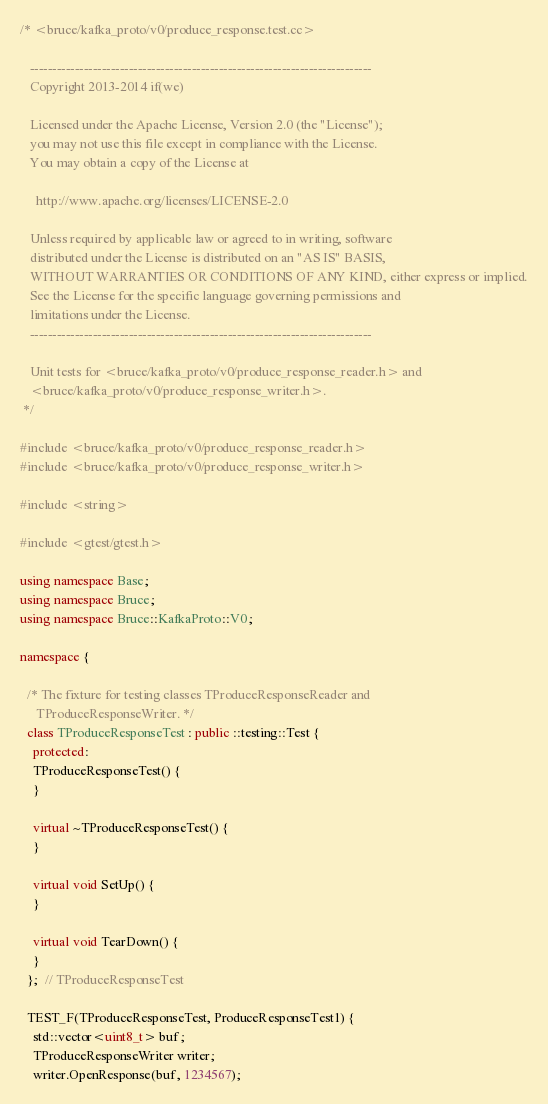Convert code to text. <code><loc_0><loc_0><loc_500><loc_500><_C++_>/* <bruce/kafka_proto/v0/produce_response.test.cc>

   ----------------------------------------------------------------------------
   Copyright 2013-2014 if(we)

   Licensed under the Apache License, Version 2.0 (the "License");
   you may not use this file except in compliance with the License.
   You may obtain a copy of the License at

     http://www.apache.org/licenses/LICENSE-2.0

   Unless required by applicable law or agreed to in writing, software
   distributed under the License is distributed on an "AS IS" BASIS,
   WITHOUT WARRANTIES OR CONDITIONS OF ANY KIND, either express or implied.
   See the License for the specific language governing permissions and
   limitations under the License.
   ----------------------------------------------------------------------------

   Unit tests for <bruce/kafka_proto/v0/produce_response_reader.h> and
   <bruce/kafka_proto/v0/produce_response_writer.h>.
 */

#include <bruce/kafka_proto/v0/produce_response_reader.h>
#include <bruce/kafka_proto/v0/produce_response_writer.h>

#include <string>

#include <gtest/gtest.h>

using namespace Base;
using namespace Bruce;
using namespace Bruce::KafkaProto::V0;

namespace {

  /* The fixture for testing classes TProduceResponseReader and
     TProduceResponseWriter. */
  class TProduceResponseTest : public ::testing::Test {
    protected:
    TProduceResponseTest() {
    }

    virtual ~TProduceResponseTest() {
    }

    virtual void SetUp() {
    }

    virtual void TearDown() {
    }
  };  // TProduceResponseTest

  TEST_F(TProduceResponseTest, ProduceResponseTest1) {
    std::vector<uint8_t> buf;
    TProduceResponseWriter writer;
    writer.OpenResponse(buf, 1234567);</code> 